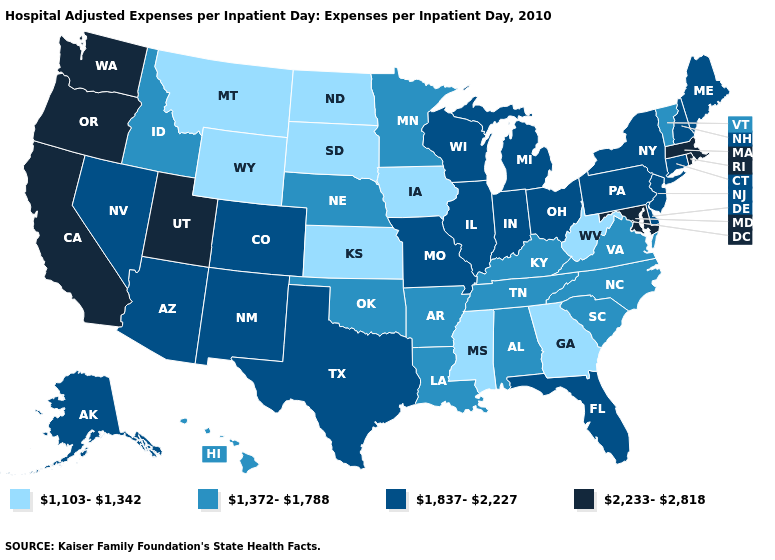What is the value of Minnesota?
Be succinct. 1,372-1,788. What is the value of Wyoming?
Concise answer only. 1,103-1,342. Does Kansas have the same value as Georgia?
Concise answer only. Yes. Name the states that have a value in the range 1,837-2,227?
Short answer required. Alaska, Arizona, Colorado, Connecticut, Delaware, Florida, Illinois, Indiana, Maine, Michigan, Missouri, Nevada, New Hampshire, New Jersey, New Mexico, New York, Ohio, Pennsylvania, Texas, Wisconsin. Does Rhode Island have the same value as Washington?
Short answer required. Yes. What is the highest value in states that border Florida?
Write a very short answer. 1,372-1,788. What is the value of Michigan?
Answer briefly. 1,837-2,227. What is the lowest value in the USA?
Concise answer only. 1,103-1,342. Among the states that border North Carolina , which have the highest value?
Write a very short answer. South Carolina, Tennessee, Virginia. What is the highest value in the USA?
Quick response, please. 2,233-2,818. Does the first symbol in the legend represent the smallest category?
Write a very short answer. Yes. Does Vermont have a higher value than New Hampshire?
Concise answer only. No. Does the first symbol in the legend represent the smallest category?
Answer briefly. Yes. What is the value of Colorado?
Concise answer only. 1,837-2,227. Does Arizona have the lowest value in the West?
Give a very brief answer. No. 